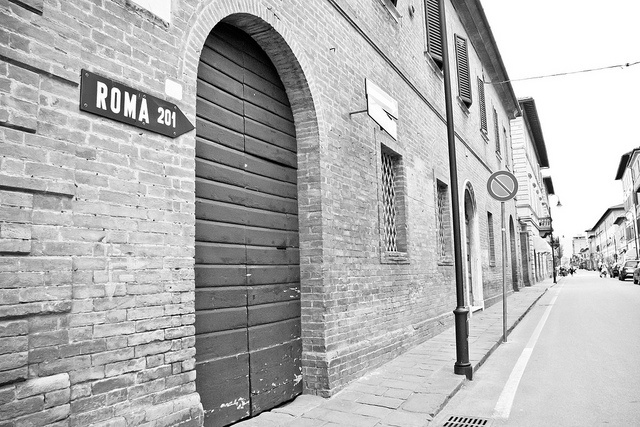Describe the objects in this image and their specific colors. I can see car in gray, lightgray, darkgray, and black tones, car in gray, black, darkgray, and lightgray tones, car in gray, darkgray, black, and lightgray tones, and people in gray, darkgray, lightgray, and black tones in this image. 